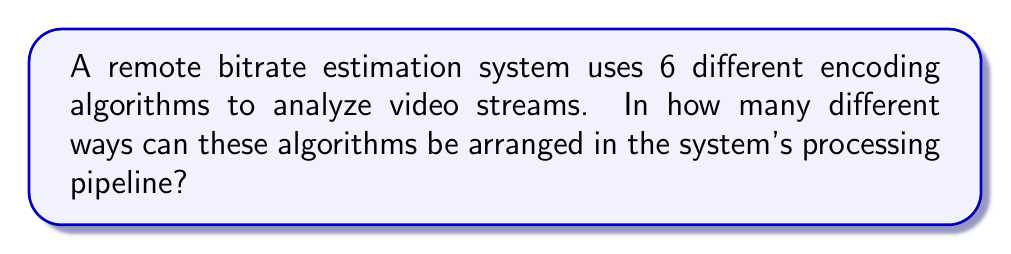Could you help me with this problem? To solve this problem, we need to consider the concept of permutations. In this case, we are arranging all 6 encoding algorithms in a specific order, and each algorithm can only be used once.

The number of permutations of n distinct objects is given by the factorial of n, denoted as n!

In this case, we have:
n = 6 (number of encoding algorithms)

Therefore, the number of different ways to arrange the algorithms is:

$$6! = 6 \times 5 \times 4 \times 3 \times 2 \times 1 = 720$$

Step-by-step calculation:
1. Start with 6 choices for the first position
2. For the second position, we have 5 remaining choices
3. For the third position, we have 4 remaining choices
4. For the fourth position, we have 3 remaining choices
5. For the fifth position, we have 2 remaining choices
6. For the last position, we have only 1 remaining choice

Multiplying these numbers together gives us the total number of permutations:

$$6 \times 5 \times 4 \times 3 \times 2 \times 1 = 720$$

This result represents all possible ways to arrange the 6 encoding algorithms in the bitrate estimation system's processing pipeline.
Answer: 720 